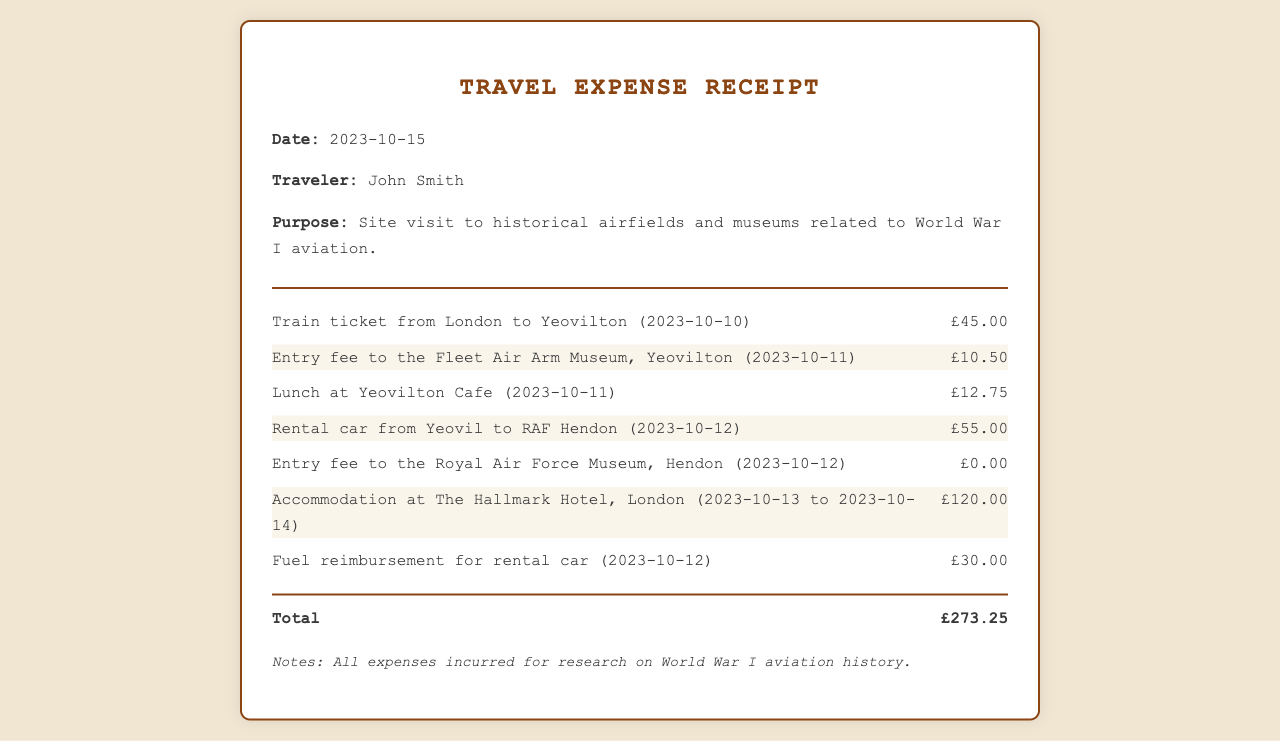What is the date of the receipt? The receipt date is specified in the document as the date it was generated, which is stated clearly at the top.
Answer: 2023-10-15 Who is the traveler named in the document? The document lists the traveler's name in the header section.
Answer: John Smith What was the total amount of expenses? The total expenses are calculated and presented at the end of the document under the total section.
Answer: £273.25 What was the purpose of the travel? The purpose of the travel is clearly stated in the document, summarizing the main reason for the trip.
Answer: Site visit to historical airfields and museums related to World War I aviation How much was spent on the train ticket? The amount for the train ticket is detailed in the list of items on the receipt.
Answer: £45.00 What did the rental car cost? The cost of the rental car is listed in the itemized expenses within the document.
Answer: £55.00 How long did the accommodation last? The document states the dates for accommodation, which indicates the duration of the stay.
Answer: 2023-10-13 to 2023-10-14 What was the entry fee for the Royal Air Force Museum? The entry fee for the Royal Air Force Museum is included in the list of expenses presented.
Answer: £0.00 What type of document is this? The document presents a specific format and purpose, which is typical for reporting expenses incurred during travel.
Answer: Travel Expense Receipt 